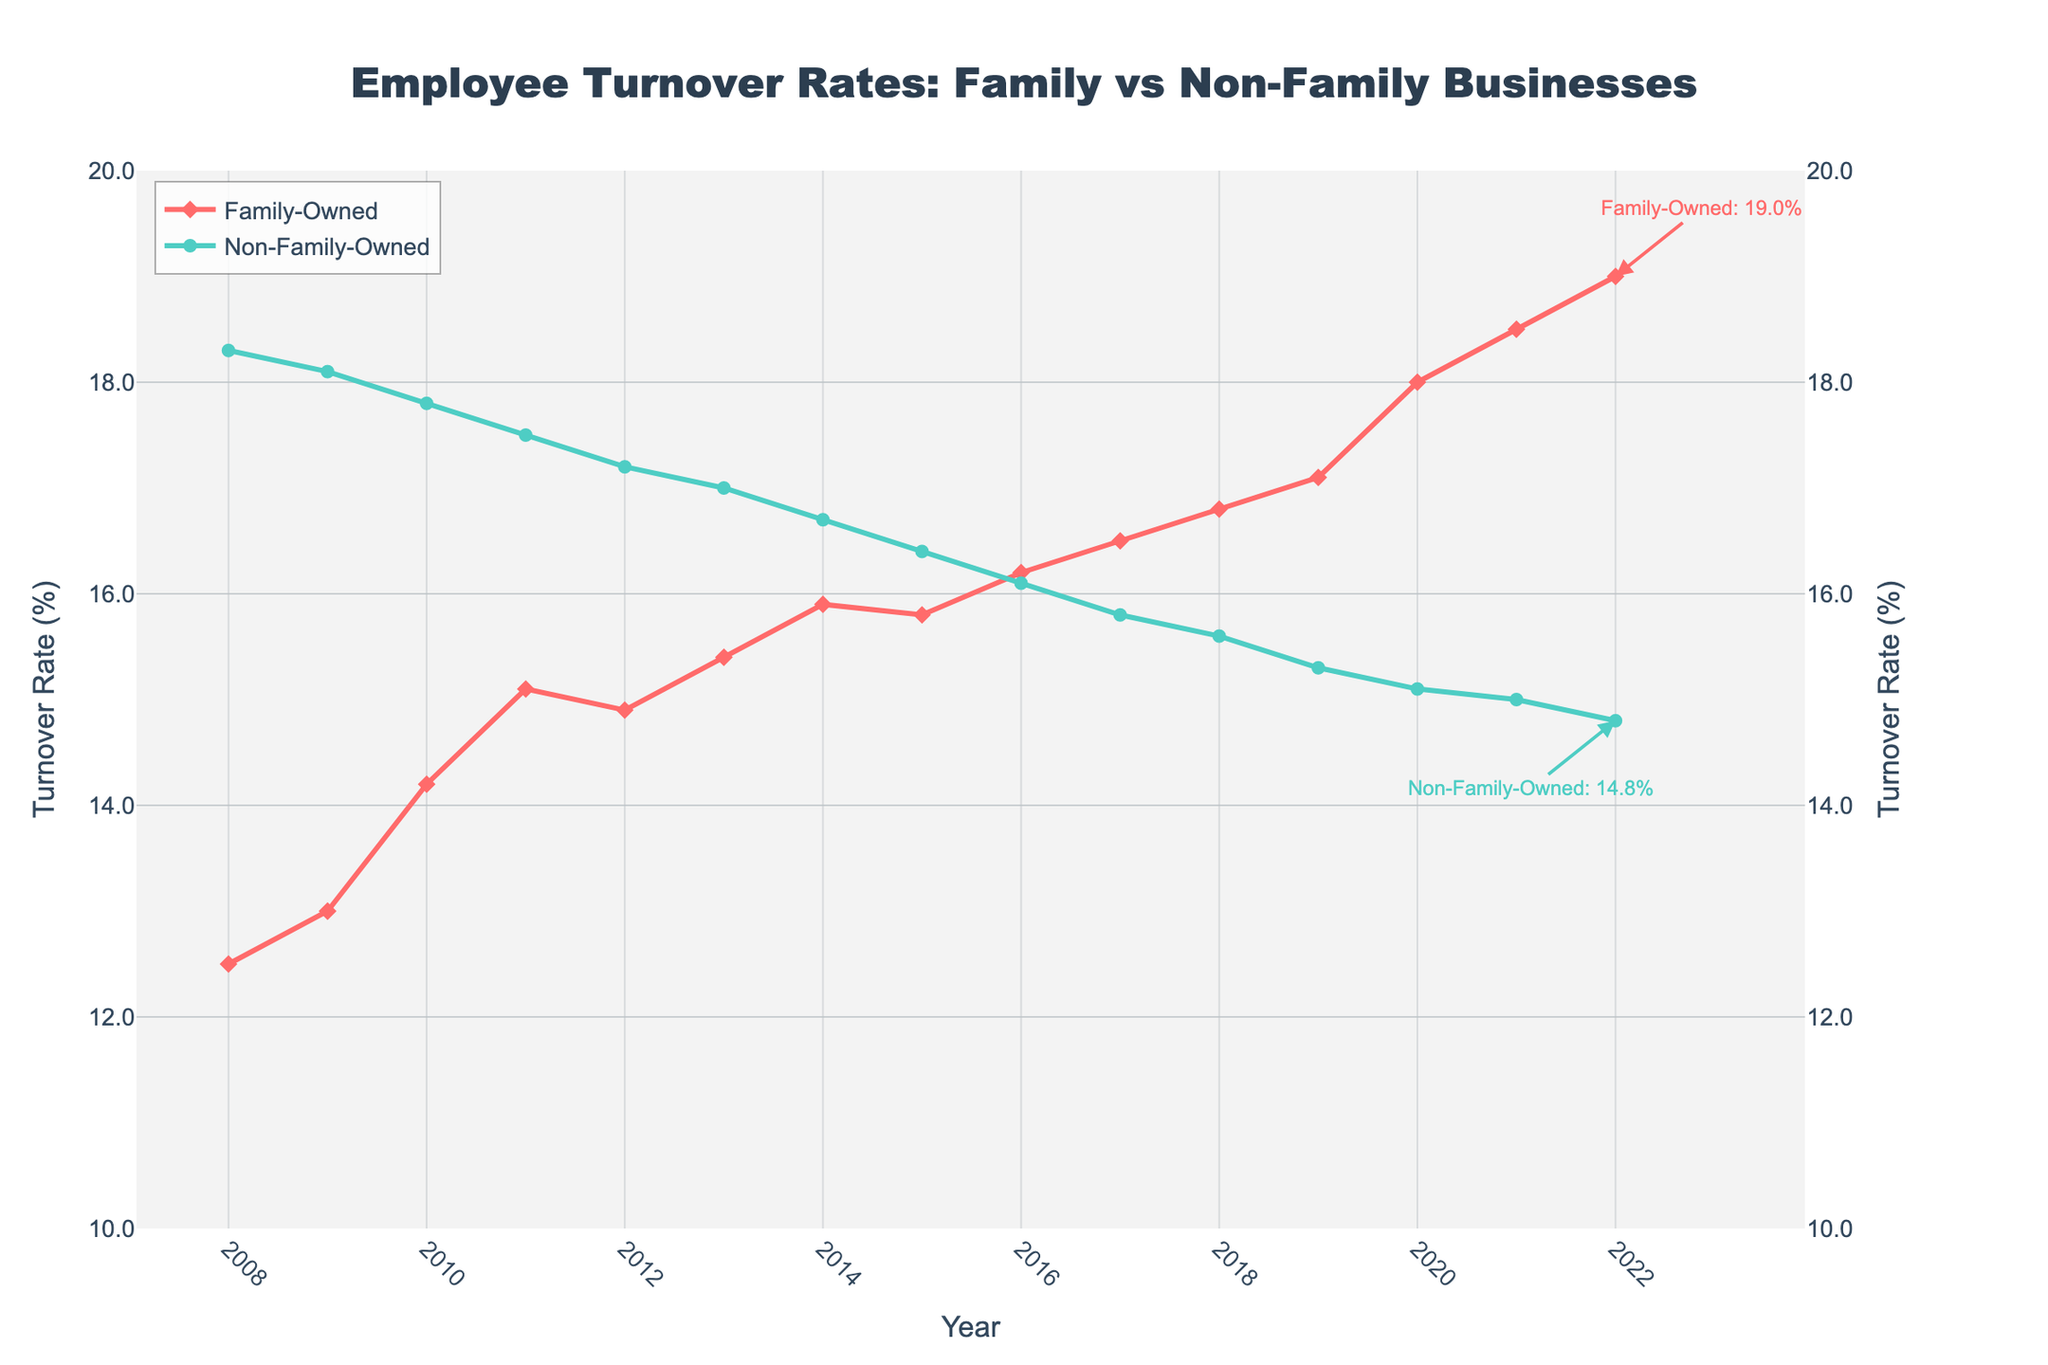What is the title of the plot? The title of the plot is prominently displayed at the top of the figure, and it reads "Employee Turnover Rates: Family vs Non-Family Businesses".
Answer: Employee Turnover Rates: Family vs Non-Family Businesses How many years are represented in the figure? The x-axis of the plot indicates the span of years from 2008 to 2022, inclusive. Count each year to find there are 15 years displayed.
Answer: 15 years Which type of business had a higher employee turnover rate in 2022? To find this, look at the end of both lines in the plot for the year 2022. The Family-Owned rate is at 19.0%, while the Non-Family-Owned rate is lower, at 14.8%.
Answer: Family-Owned What was the turnover rate for Non-Family-Owned businesses in 2010? Find the point corresponding to 2010 on the Non-Family-Owned line, which is marked with circles. The turnover rate reads 17.8%.
Answer: 17.8% What is the general trend of turnover rates for Family-Owned businesses over the past 15 years? Observe that the Family-Owned line consistently trends upwards from 12.5% in 2008 to 19.0% in 2022.
Answer: Increasing When did the Non-Family-Owned businesses have the lowest turnover rate, and what was it? Look at the Non-Family-Owned line (green circles) and find the lowest point, which is in 2022 at a rate of 14.8%.
Answer: 2022, 14.8% What is the difference in turnover rates between Family-Owned and Non-Family-Owned businesses in 2016? Check both lines at 2016: Family-Owned is at 16.2% and Non-Family-Owned is at 16.1%. The difference is 16.2% - 16.1% = 0.1%.
Answer: 0.1% Which year had the highest turnover rate for Family-Owned businesses? Follow the Family-Owned line, noting the highest point in 2022 at 19.0%.
Answer: 2022 By how much did the turnover rate for Non-Family-Owned businesses drop from 2008 to 2022? Compare the turnover rate for 2008 (18.3%) to 2022 (14.8%): the drop is 18.3% - 14.8% = 3.5%.
Answer: 3.5% What is the average turnover rate for Family-Owned businesses over the 15-year period? Sum all Family-Owned turnover rates and divide by 15: 
(12.5 + 13.0 + 14.2 + 15.1 + 14.9 + 15.4 + 15.9 + 15.8 + 16.2 + 16.5 + 16.8 + 17.1 + 18.0 + 18.5 + 19.0) / 15 = 16.02%.
Answer: 16.02% 